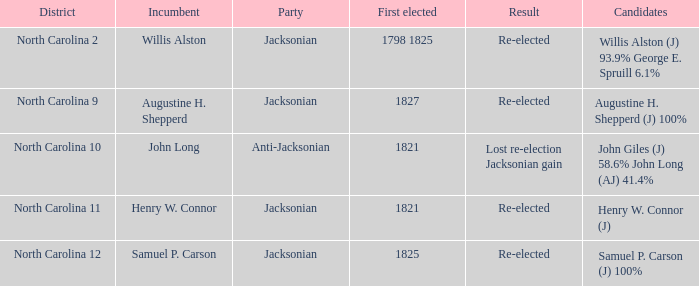What is the outcome for augustine h. shepperd (j) with 100%? Re-elected. Could you help me parse every detail presented in this table? {'header': ['District', 'Incumbent', 'Party', 'First elected', 'Result', 'Candidates'], 'rows': [['North Carolina 2', 'Willis Alston', 'Jacksonian', '1798 1825', 'Re-elected', 'Willis Alston (J) 93.9% George E. Spruill 6.1%'], ['North Carolina 9', 'Augustine H. Shepperd', 'Jacksonian', '1827', 'Re-elected', 'Augustine H. Shepperd (J) 100%'], ['North Carolina 10', 'John Long', 'Anti-Jacksonian', '1821', 'Lost re-election Jacksonian gain', 'John Giles (J) 58.6% John Long (AJ) 41.4%'], ['North Carolina 11', 'Henry W. Connor', 'Jacksonian', '1821', 'Re-elected', 'Henry W. Connor (J)'], ['North Carolina 12', 'Samuel P. Carson', 'Jacksonian', '1825', 'Re-elected', 'Samuel P. Carson (J) 100%']]} 